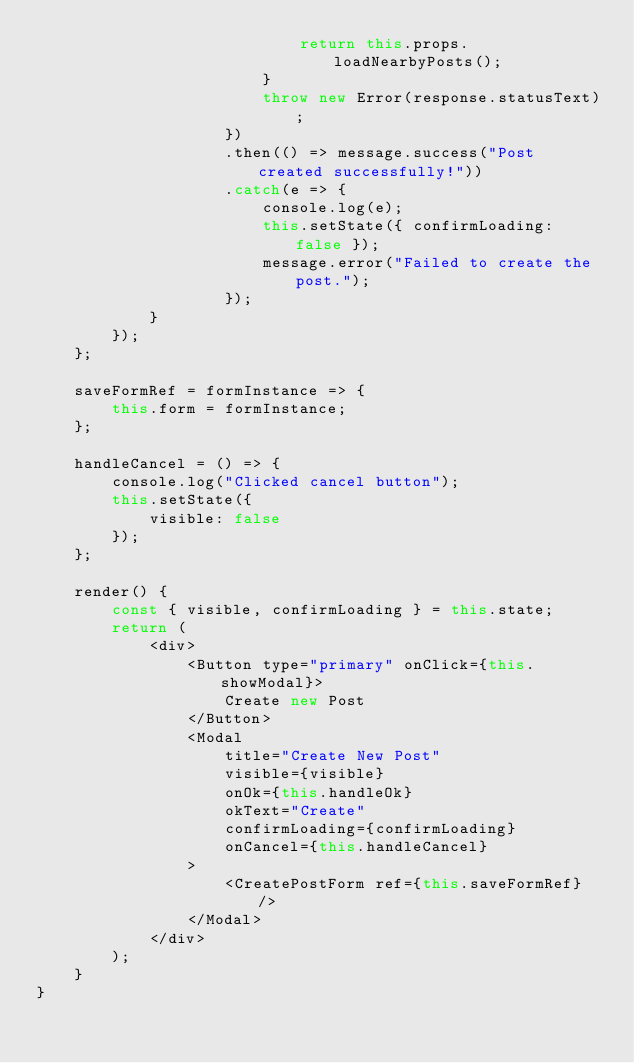Convert code to text. <code><loc_0><loc_0><loc_500><loc_500><_JavaScript_>                            return this.props.loadNearbyPosts();
                        }
                        throw new Error(response.statusText);
                    })
                    .then(() => message.success("Post created successfully!"))
                    .catch(e => {
                        console.log(e);
                        this.setState({ confirmLoading: false });
                        message.error("Failed to create the post.");
                    });
            }
        });
    };

    saveFormRef = formInstance => {
        this.form = formInstance;
    };

    handleCancel = () => {
        console.log("Clicked cancel button");
        this.setState({
            visible: false
        });
    };

    render() {
        const { visible, confirmLoading } = this.state;
        return (
            <div>
                <Button type="primary" onClick={this.showModal}>
                    Create new Post
                </Button>
                <Modal
                    title="Create New Post"
                    visible={visible}
                    onOk={this.handleOk}
                    okText="Create"
                    confirmLoading={confirmLoading}
                    onCancel={this.handleCancel}
                >
                    <CreatePostForm ref={this.saveFormRef} />
                </Modal>
            </div>
        );
    }
}
</code> 